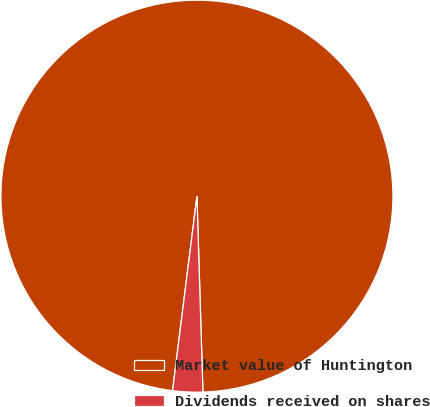Convert chart. <chart><loc_0><loc_0><loc_500><loc_500><pie_chart><fcel>Market value of Huntington<fcel>Dividends received on shares<nl><fcel>97.53%<fcel>2.47%<nl></chart> 